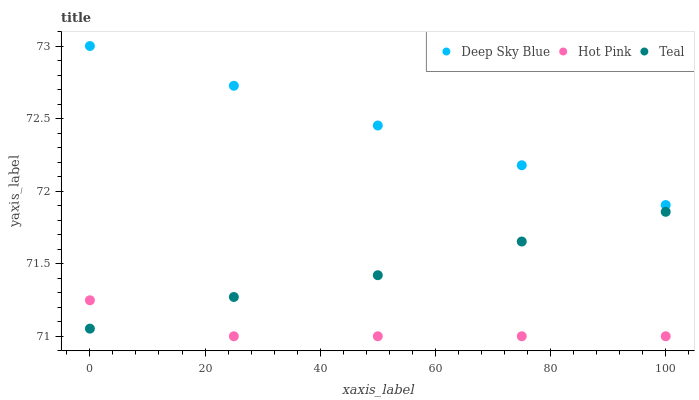Does Hot Pink have the minimum area under the curve?
Answer yes or no. Yes. Does Deep Sky Blue have the maximum area under the curve?
Answer yes or no. Yes. Does Teal have the minimum area under the curve?
Answer yes or no. No. Does Teal have the maximum area under the curve?
Answer yes or no. No. Is Deep Sky Blue the smoothest?
Answer yes or no. Yes. Is Hot Pink the roughest?
Answer yes or no. Yes. Is Teal the smoothest?
Answer yes or no. No. Is Teal the roughest?
Answer yes or no. No. Does Hot Pink have the lowest value?
Answer yes or no. Yes. Does Teal have the lowest value?
Answer yes or no. No. Does Deep Sky Blue have the highest value?
Answer yes or no. Yes. Does Teal have the highest value?
Answer yes or no. No. Is Hot Pink less than Deep Sky Blue?
Answer yes or no. Yes. Is Deep Sky Blue greater than Teal?
Answer yes or no. Yes. Does Teal intersect Hot Pink?
Answer yes or no. Yes. Is Teal less than Hot Pink?
Answer yes or no. No. Is Teal greater than Hot Pink?
Answer yes or no. No. Does Hot Pink intersect Deep Sky Blue?
Answer yes or no. No. 